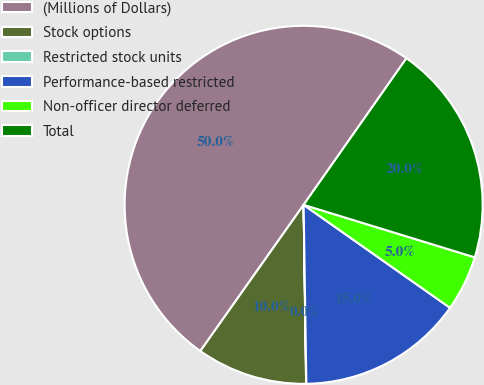Convert chart to OTSL. <chart><loc_0><loc_0><loc_500><loc_500><pie_chart><fcel>(Millions of Dollars)<fcel>Stock options<fcel>Restricted stock units<fcel>Performance-based restricted<fcel>Non-officer director deferred<fcel>Total<nl><fcel>49.95%<fcel>10.01%<fcel>0.02%<fcel>15.0%<fcel>5.02%<fcel>20.0%<nl></chart> 